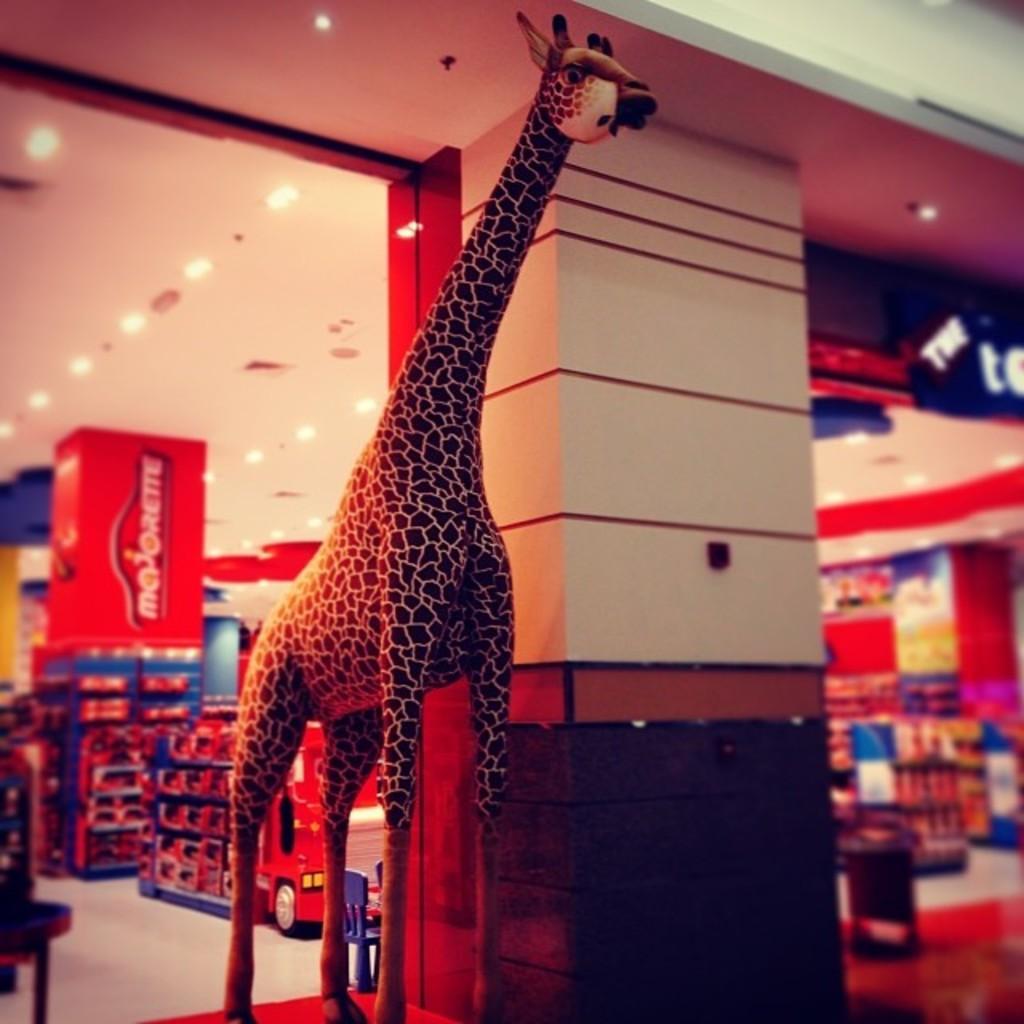In one or two sentences, can you explain what this image depicts? In this picture we can see a depiction of a giraffe. In the background we can see a store. We can see objects, lights, board, ceiling, floor and pillar. 